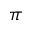Convert formula to latex. <formula><loc_0><loc_0><loc_500><loc_500>\pi</formula> 